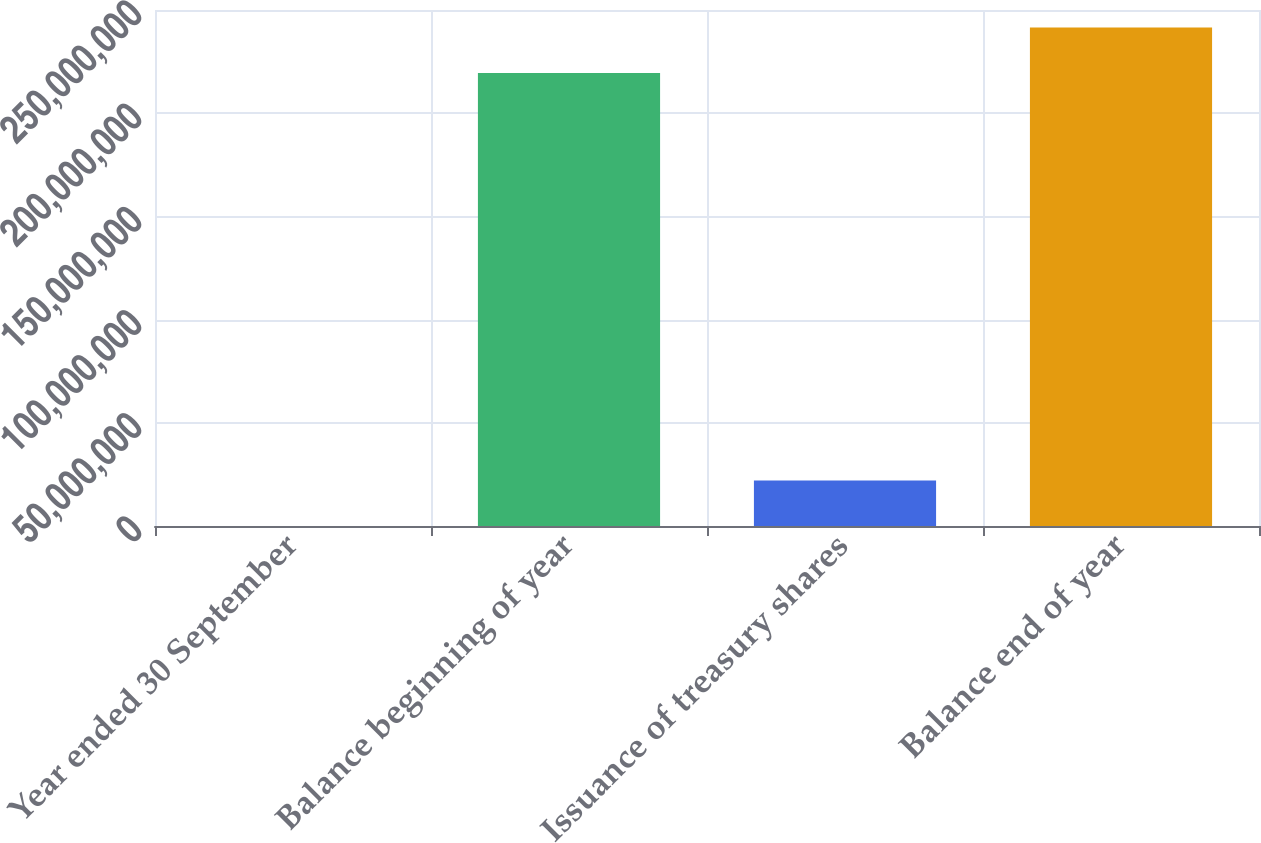<chart> <loc_0><loc_0><loc_500><loc_500><bar_chart><fcel>Year ended 30 September<fcel>Balance beginning of year<fcel>Issuance of treasury shares<fcel>Balance end of year<nl><fcel>2019<fcel>2.19515e+08<fcel>2.20433e+07<fcel>2.41557e+08<nl></chart> 